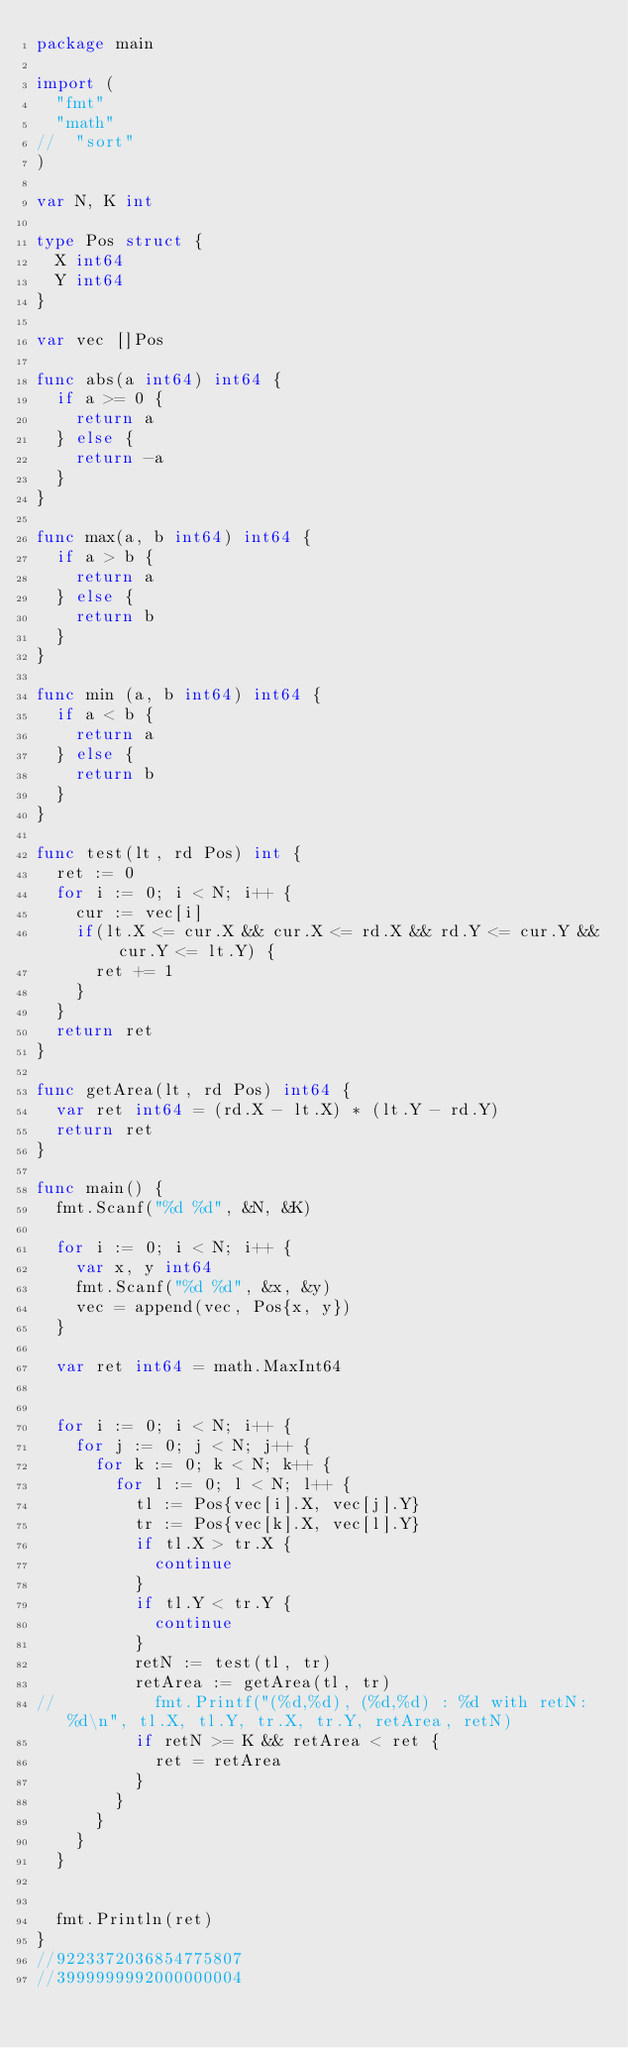Convert code to text. <code><loc_0><loc_0><loc_500><loc_500><_Go_>package main

import (
  "fmt"
  "math"
//  "sort"
)

var N, K int

type Pos struct {
  X int64
  Y int64
}

var vec []Pos

func abs(a int64) int64 {
  if a >= 0 {
    return a
  } else {
    return -a
  }
}

func max(a, b int64) int64 {
  if a > b {
    return a
  } else {
    return b
  }
}

func min (a, b int64) int64 {
  if a < b {
    return a
  } else {
    return b
  }
}

func test(lt, rd Pos) int {
  ret := 0
  for i := 0; i < N; i++ {
    cur := vec[i]
    if(lt.X <= cur.X && cur.X <= rd.X && rd.Y <= cur.Y && cur.Y <= lt.Y) {
      ret += 1
    }
  }
  return ret
}

func getArea(lt, rd Pos) int64 {
  var ret int64 = (rd.X - lt.X) * (lt.Y - rd.Y)
  return ret
}

func main() {
  fmt.Scanf("%d %d", &N, &K)

  for i := 0; i < N; i++ {
    var x, y int64
    fmt.Scanf("%d %d", &x, &y)
    vec = append(vec, Pos{x, y})
  }

  var ret int64 = math.MaxInt64


  for i := 0; i < N; i++ {
    for j := 0; j < N; j++ {
      for k := 0; k < N; k++ {
        for l := 0; l < N; l++ {
          tl := Pos{vec[i].X, vec[j].Y}
          tr := Pos{vec[k].X, vec[l].Y}
          if tl.X > tr.X {
            continue
          }
          if tl.Y < tr.Y {
            continue
          }
          retN := test(tl, tr)
          retArea := getArea(tl, tr)
//          fmt.Printf("(%d,%d), (%d,%d) : %d with retN: %d\n", tl.X, tl.Y, tr.X, tr.Y, retArea, retN)
          if retN >= K && retArea < ret {
            ret = retArea
          }
        }
      }
    }
  }


  fmt.Println(ret)
}
//9223372036854775807
//3999999992000000004
</code> 